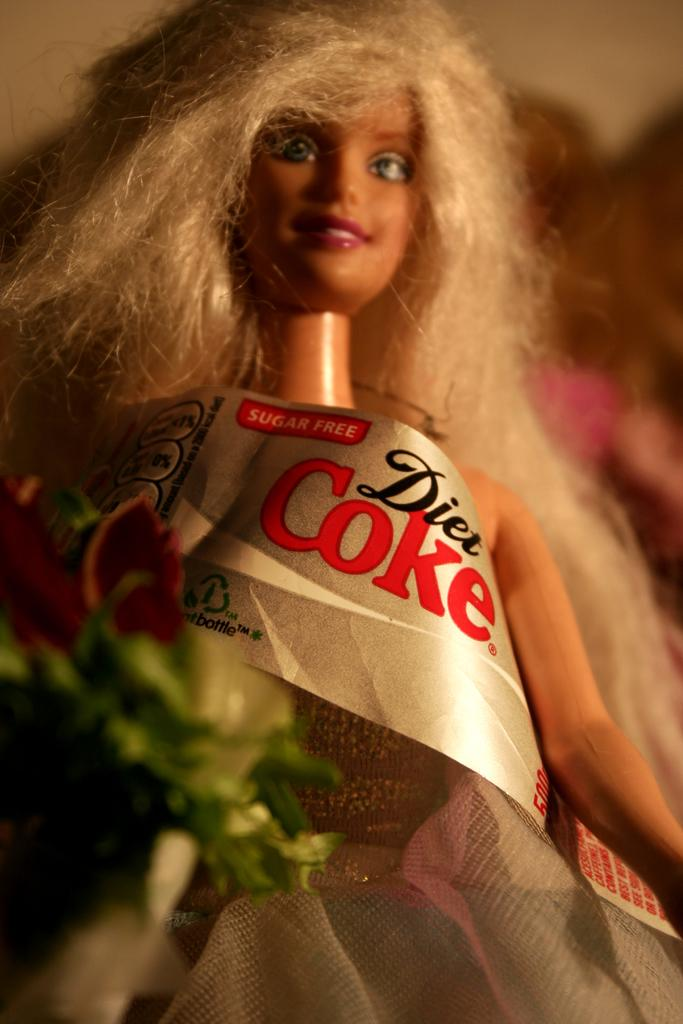What is the main subject of the image? The main subject of the image is a doll. What is the doll wearing or holding in the image? The doll is wearing a tag for a sugar-free Diet Coke. What type of coal is being used to cast the doll in the image? There is no indication in the image that the doll is being cast or that coal is being used in any way. 